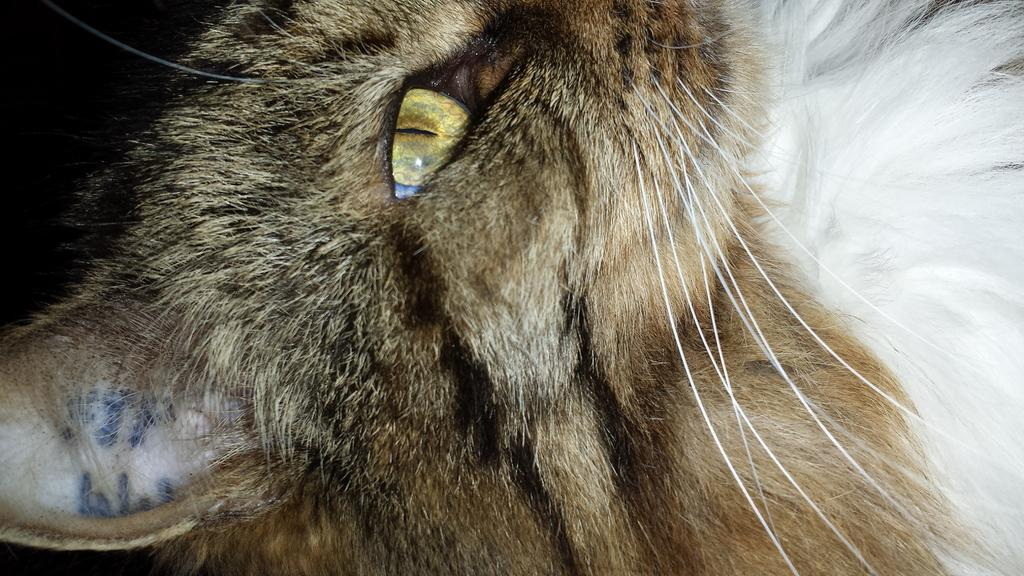What is the main subject of the image? There is a close view of a cat in the image. Can you describe the background of the image? The background of the image is dark. What type of flame can be seen in the image? There is no flame present in the image; it features a close view of a cat with a dark background. What type of discovery is being made in the image? There is no discovery being made in the image; it simply shows a close view of a cat with a dark background. 